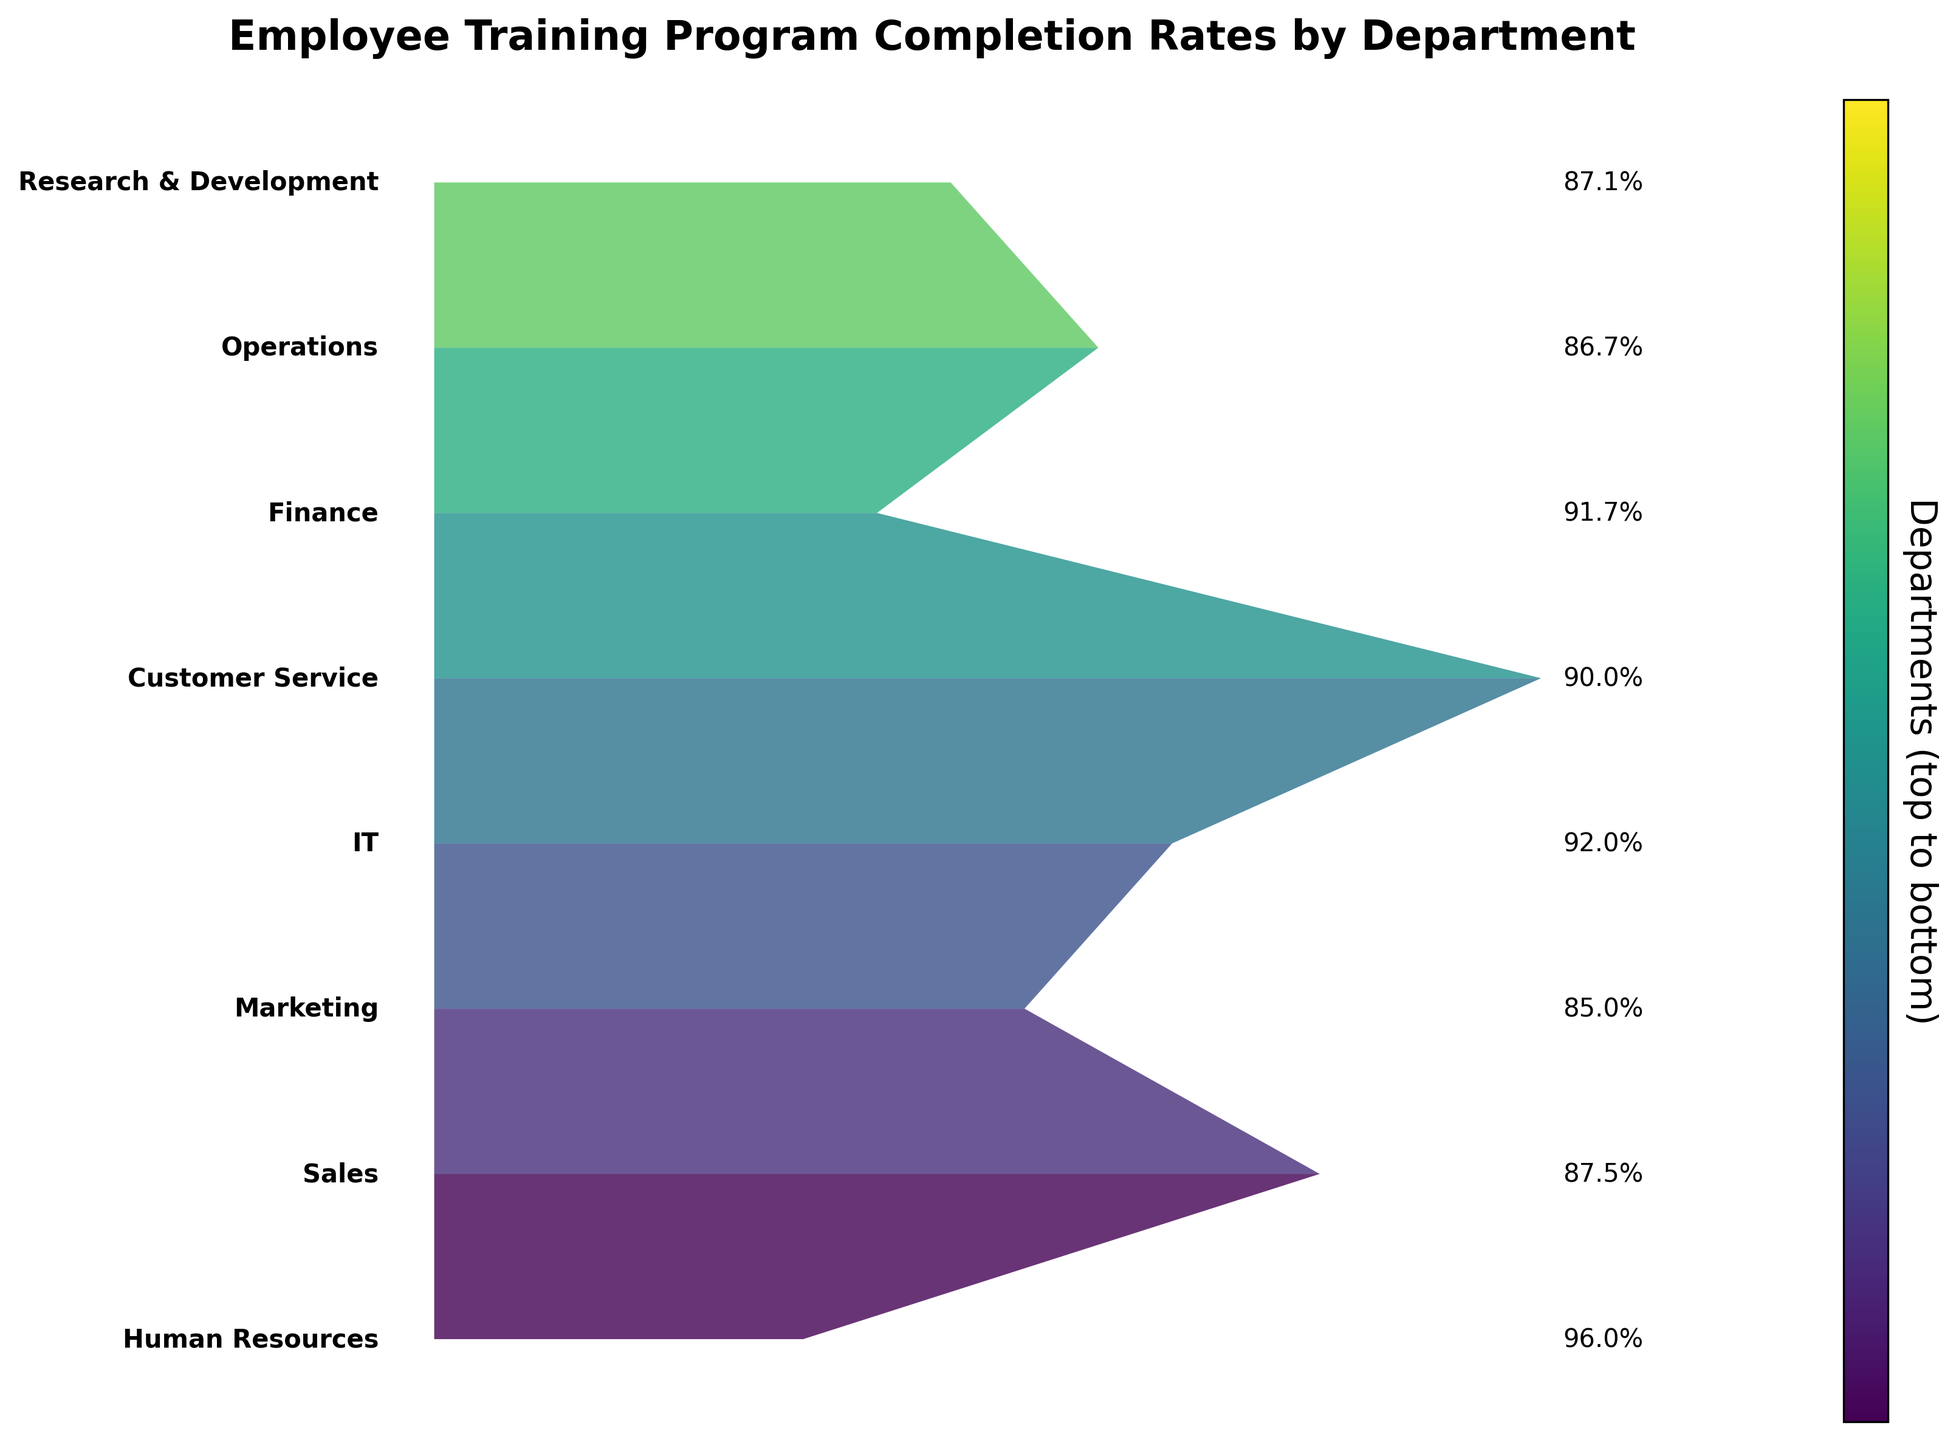What is the title of the funnel chart? The title of the funnel chart is usually located at the top of the chart and provides an overview of what the chart represents. In this case, it should state the topic of the chart.
Answer: Employee Training Program Completion Rates by Department Which department has the highest completion rate? The completion rate can be seen next to the department labels on the right side of the funnel chart. The highest rate is the maximum value among these percentages.
Answer: Customer Service What is the completion rate for the IT department? Find the IT department label on the y-axis and look at the percentage completion rate next to it on the right.
Answer: 92.0% Which department has the lowest number of employees who completed the training? The number of employees who completed the training is indicated next to each department. The department with the lowest number should be identified.
Answer: Finance How many more employees completed the training in the Customer Service department compared to the IT department? Calculate the difference between the number of employees who completed the training in both departments: 135 (Customer Service) - 92 (IT).
Answer: 43 What is the average completion rate across all departments? To find the average completion rate, sum the completion percentages of all departments and divide by the number of departments. Calculation: (96% + 87.5% + 85% + 92% + 90% + 91.7% + 86.7% + 87.1%) / 8.
Answer: 89.5% Compare the completion rate between the Marketing and Operations departments. Which one is higher? Find the completion rates for both departments and compare: Marketing (85%) and Operations (86.7%). Operations has the higher rate.
Answer: Operations Which department has the largest difference between the number of employees and those who completed the training? To find the largest difference, subtract the number of completed training from total employees for each department and identify the maximum value: e.g., 150 - 135 for Customer Service, etc.
Answer: Sales What is the sum of all employees across all departments? Add the total number of employees in all departments: 50 + 120 + 80 + 100 + 150 + 60 + 90 + 70.
Answer: 720 What is the completion rate for employees in the Human Resources department? Find the Human Resources department label on the y-axis and locate the corresponding completion rate on the right: 96%.
Answer: 96% 